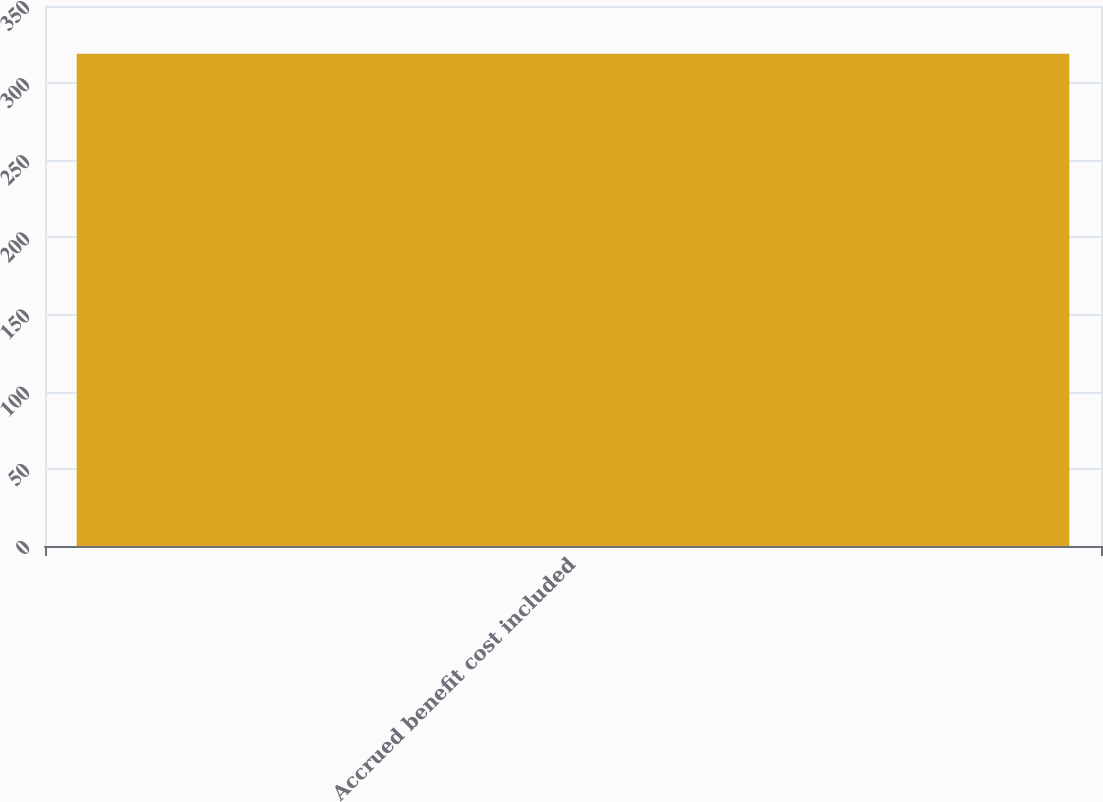Convert chart to OTSL. <chart><loc_0><loc_0><loc_500><loc_500><bar_chart><fcel>Accrued benefit cost included<nl><fcel>319<nl></chart> 